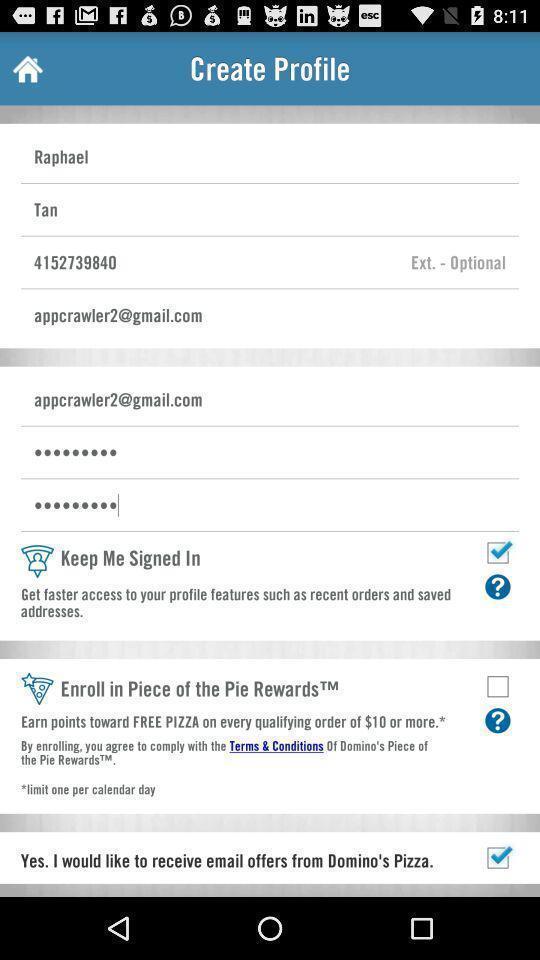Provide a detailed account of this screenshot. Screen displaying the profile page. 